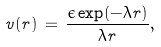Convert formula to latex. <formula><loc_0><loc_0><loc_500><loc_500>v ( r ) \, = \, \frac { \epsilon \exp ( - \lambda r ) } { \lambda r } ,</formula> 